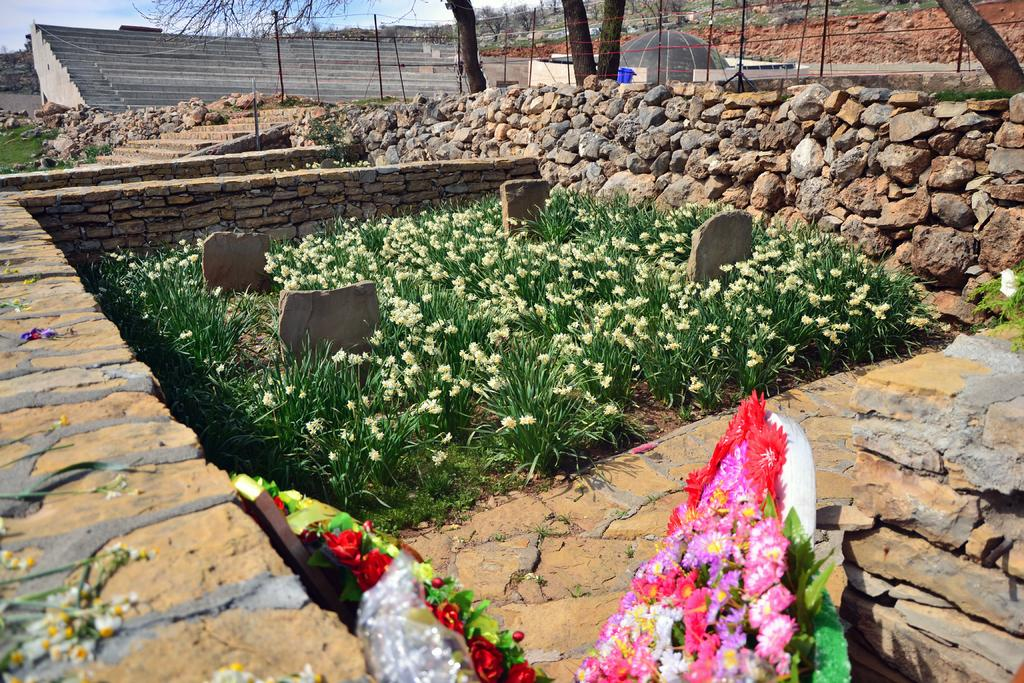What type of vegetation is located in the center of the image? There are shrubs in the center of the image. What can be seen at the bottom of the image? There are bouquets at the bottom of the image. What type of structure is on the right side of the image? There is a rock wall on the right side of the image. What is visible in the background of the image? There are trees and stairs in the background of the image. Can you tell me how many umbrellas are open in the image? There are no umbrellas present in the image. What type of paper is being used to create the rock wall in the image? There is no paper used to create the rock wall in the image; it is made of actual rocks. 